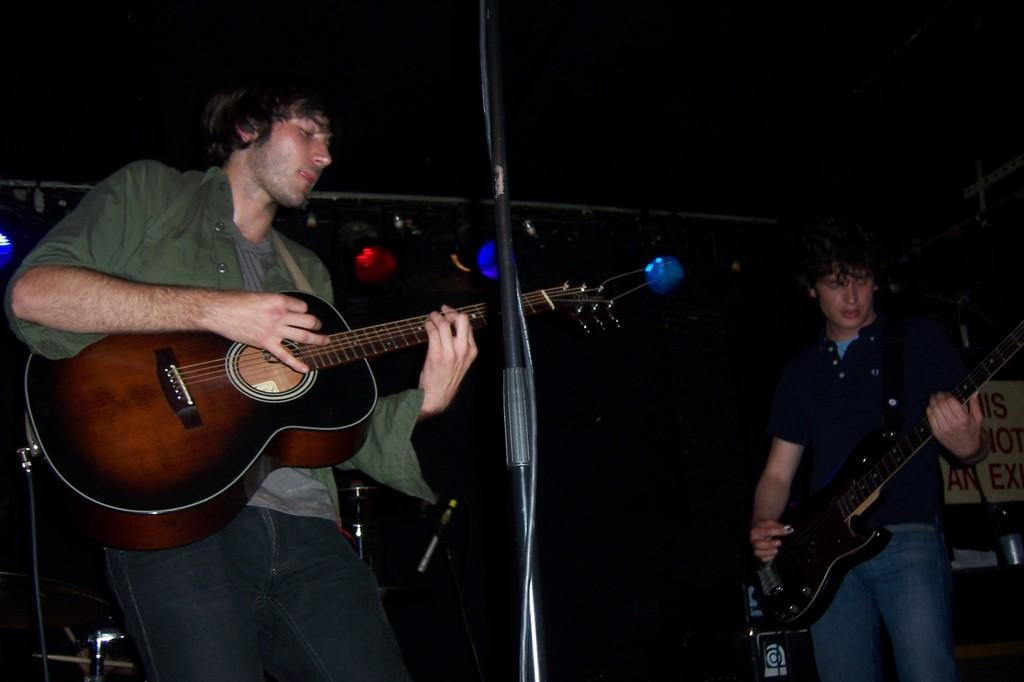Who is the main subject in the image? There is a man in the image. What is the man doing in the image? The man is standing and playing the guitar. What object is the man holding in the image? The man is holding a guitar. What is in front of the man in the image? There is a microphone stand in front of the man. Where can the books be found in the image? There are no books present in the image. What time is it according to the clock in the image? There is no clock present in the image. 